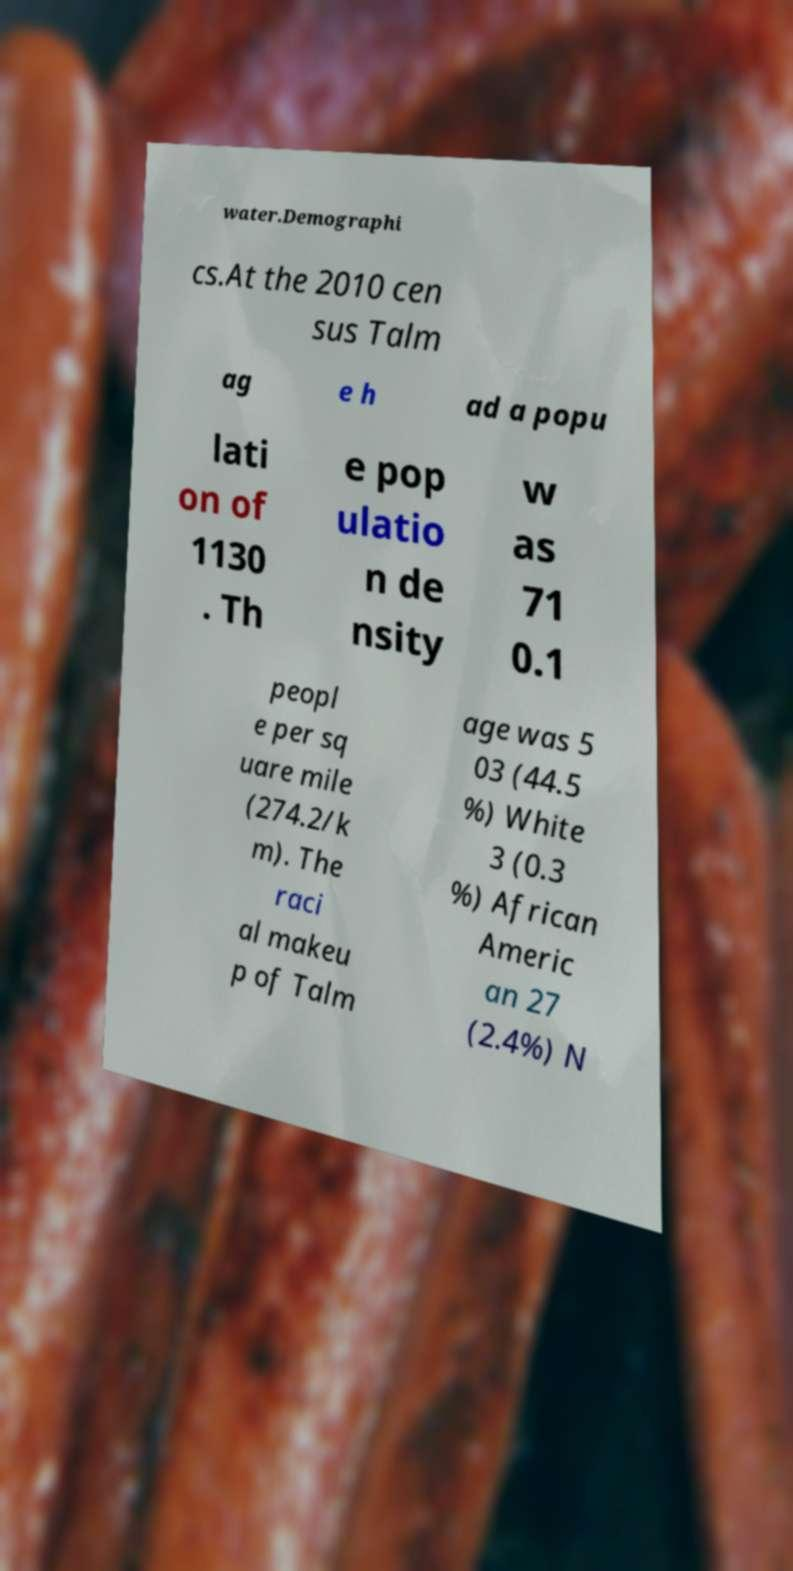There's text embedded in this image that I need extracted. Can you transcribe it verbatim? water.Demographi cs.At the 2010 cen sus Talm ag e h ad a popu lati on of 1130 . Th e pop ulatio n de nsity w as 71 0.1 peopl e per sq uare mile (274.2/k m). The raci al makeu p of Talm age was 5 03 (44.5 %) White 3 (0.3 %) African Americ an 27 (2.4%) N 